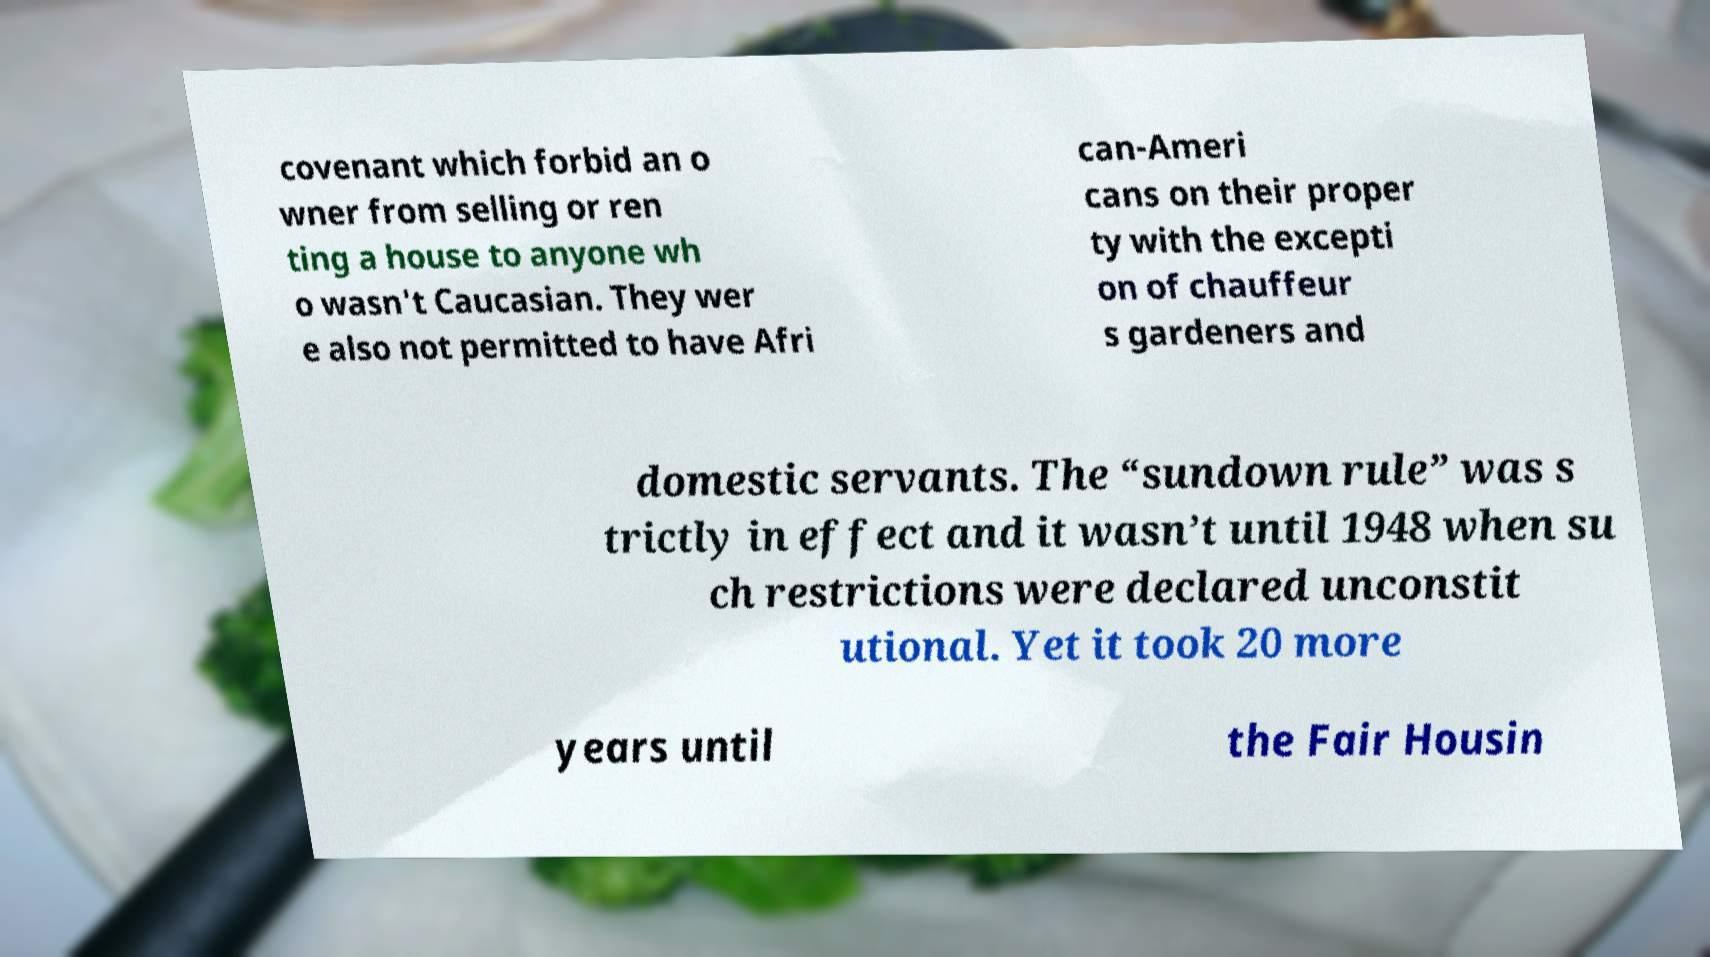Could you extract and type out the text from this image? covenant which forbid an o wner from selling or ren ting a house to anyone wh o wasn't Caucasian. They wer e also not permitted to have Afri can-Ameri cans on their proper ty with the excepti on of chauffeur s gardeners and domestic servants. The “sundown rule” was s trictly in effect and it wasn’t until 1948 when su ch restrictions were declared unconstit utional. Yet it took 20 more years until the Fair Housin 